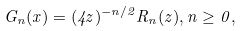<formula> <loc_0><loc_0><loc_500><loc_500>G _ { n } ( x ) = ( 4 z ) ^ { - n / 2 } R _ { n } ( z ) , n \geq 0 ,</formula> 